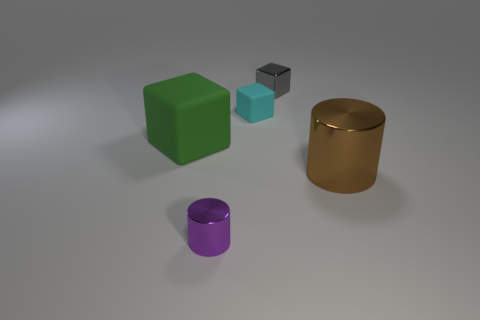How many rubber things are to the right of the shiny thing that is in front of the big cylinder that is to the right of the large matte object?
Provide a short and direct response. 1. What color is the tiny shiny object that is behind the rubber thing left of the purple object?
Offer a terse response. Gray. Are there any red rubber things of the same size as the purple cylinder?
Keep it short and to the point. No. What is the material of the block left of the rubber cube that is behind the rubber block that is on the left side of the cyan block?
Your response must be concise. Rubber. How many big matte objects are in front of the cylinder that is right of the cyan matte object?
Your answer should be very brief. 0. There is a rubber thing that is on the right side of the purple shiny cylinder; is its size the same as the purple metallic cylinder?
Ensure brevity in your answer.  Yes. How many purple things are the same shape as the brown object?
Offer a terse response. 1. What shape is the small cyan thing?
Provide a short and direct response. Cube. Are there an equal number of gray things that are left of the purple metal cylinder and matte cylinders?
Make the answer very short. Yes. Do the big thing to the right of the gray cube and the big cube have the same material?
Give a very brief answer. No. 